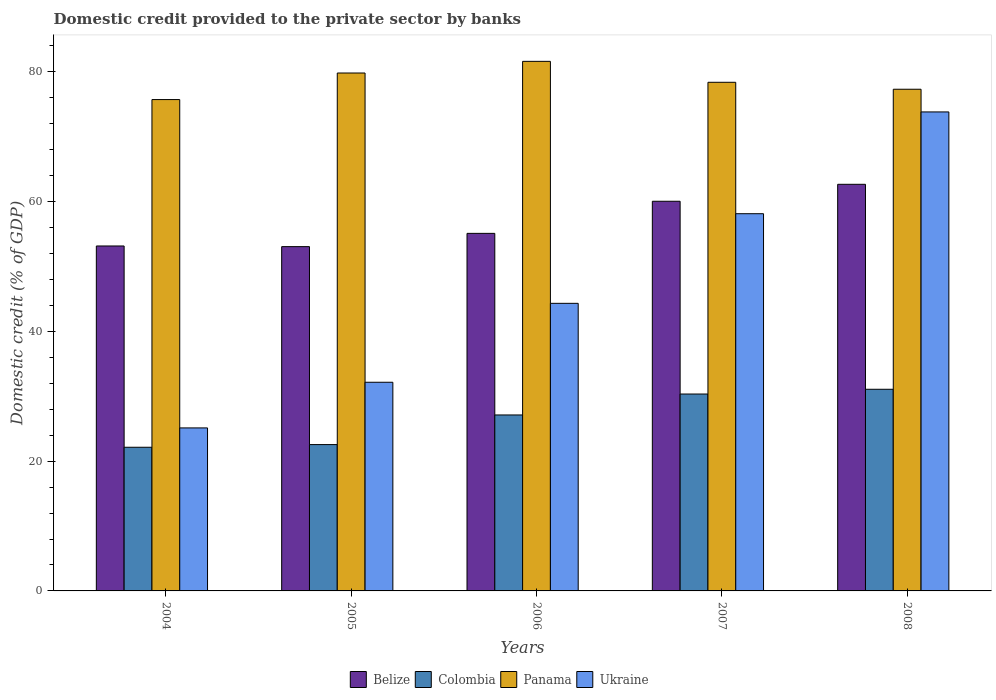Are the number of bars per tick equal to the number of legend labels?
Your answer should be very brief. Yes. How many bars are there on the 5th tick from the left?
Offer a terse response. 4. How many bars are there on the 2nd tick from the right?
Offer a terse response. 4. What is the label of the 4th group of bars from the left?
Your answer should be very brief. 2007. What is the domestic credit provided to the private sector by banks in Colombia in 2005?
Your answer should be compact. 22.56. Across all years, what is the maximum domestic credit provided to the private sector by banks in Colombia?
Keep it short and to the point. 31.08. Across all years, what is the minimum domestic credit provided to the private sector by banks in Panama?
Your answer should be very brief. 75.74. In which year was the domestic credit provided to the private sector by banks in Panama maximum?
Give a very brief answer. 2006. What is the total domestic credit provided to the private sector by banks in Ukraine in the graph?
Ensure brevity in your answer.  233.59. What is the difference between the domestic credit provided to the private sector by banks in Ukraine in 2006 and that in 2008?
Ensure brevity in your answer.  -29.5. What is the difference between the domestic credit provided to the private sector by banks in Colombia in 2008 and the domestic credit provided to the private sector by banks in Belize in 2005?
Provide a short and direct response. -21.99. What is the average domestic credit provided to the private sector by banks in Ukraine per year?
Make the answer very short. 46.72. In the year 2005, what is the difference between the domestic credit provided to the private sector by banks in Colombia and domestic credit provided to the private sector by banks in Belize?
Make the answer very short. -30.51. In how many years, is the domestic credit provided to the private sector by banks in Panama greater than 20 %?
Offer a terse response. 5. What is the ratio of the domestic credit provided to the private sector by banks in Colombia in 2006 to that in 2007?
Your answer should be very brief. 0.89. What is the difference between the highest and the second highest domestic credit provided to the private sector by banks in Panama?
Offer a terse response. 1.8. What is the difference between the highest and the lowest domestic credit provided to the private sector by banks in Ukraine?
Offer a terse response. 48.71. In how many years, is the domestic credit provided to the private sector by banks in Ukraine greater than the average domestic credit provided to the private sector by banks in Ukraine taken over all years?
Offer a terse response. 2. Is the sum of the domestic credit provided to the private sector by banks in Belize in 2006 and 2008 greater than the maximum domestic credit provided to the private sector by banks in Ukraine across all years?
Your answer should be very brief. Yes. What does the 2nd bar from the left in 2008 represents?
Ensure brevity in your answer.  Colombia. What does the 2nd bar from the right in 2008 represents?
Offer a very short reply. Panama. Are all the bars in the graph horizontal?
Make the answer very short. No. How many years are there in the graph?
Provide a short and direct response. 5. Does the graph contain grids?
Make the answer very short. No. What is the title of the graph?
Your response must be concise. Domestic credit provided to the private sector by banks. What is the label or title of the X-axis?
Keep it short and to the point. Years. What is the label or title of the Y-axis?
Ensure brevity in your answer.  Domestic credit (% of GDP). What is the Domestic credit (% of GDP) in Belize in 2004?
Make the answer very short. 53.17. What is the Domestic credit (% of GDP) in Colombia in 2004?
Provide a short and direct response. 22.15. What is the Domestic credit (% of GDP) in Panama in 2004?
Offer a very short reply. 75.74. What is the Domestic credit (% of GDP) of Ukraine in 2004?
Your answer should be compact. 25.13. What is the Domestic credit (% of GDP) in Belize in 2005?
Offer a very short reply. 53.07. What is the Domestic credit (% of GDP) in Colombia in 2005?
Your response must be concise. 22.56. What is the Domestic credit (% of GDP) of Panama in 2005?
Make the answer very short. 79.83. What is the Domestic credit (% of GDP) of Ukraine in 2005?
Provide a succinct answer. 32.16. What is the Domestic credit (% of GDP) of Belize in 2006?
Your answer should be compact. 55.11. What is the Domestic credit (% of GDP) of Colombia in 2006?
Offer a very short reply. 27.12. What is the Domestic credit (% of GDP) of Panama in 2006?
Offer a terse response. 81.63. What is the Domestic credit (% of GDP) of Ukraine in 2006?
Give a very brief answer. 44.33. What is the Domestic credit (% of GDP) of Belize in 2007?
Offer a terse response. 60.06. What is the Domestic credit (% of GDP) of Colombia in 2007?
Provide a succinct answer. 30.35. What is the Domestic credit (% of GDP) in Panama in 2007?
Give a very brief answer. 78.4. What is the Domestic credit (% of GDP) in Ukraine in 2007?
Make the answer very short. 58.14. What is the Domestic credit (% of GDP) in Belize in 2008?
Offer a very short reply. 62.68. What is the Domestic credit (% of GDP) in Colombia in 2008?
Keep it short and to the point. 31.08. What is the Domestic credit (% of GDP) of Panama in 2008?
Your answer should be compact. 77.33. What is the Domestic credit (% of GDP) of Ukraine in 2008?
Offer a terse response. 73.83. Across all years, what is the maximum Domestic credit (% of GDP) in Belize?
Ensure brevity in your answer.  62.68. Across all years, what is the maximum Domestic credit (% of GDP) of Colombia?
Offer a very short reply. 31.08. Across all years, what is the maximum Domestic credit (% of GDP) in Panama?
Provide a short and direct response. 81.63. Across all years, what is the maximum Domestic credit (% of GDP) of Ukraine?
Ensure brevity in your answer.  73.83. Across all years, what is the minimum Domestic credit (% of GDP) in Belize?
Provide a succinct answer. 53.07. Across all years, what is the minimum Domestic credit (% of GDP) of Colombia?
Provide a short and direct response. 22.15. Across all years, what is the minimum Domestic credit (% of GDP) of Panama?
Your response must be concise. 75.74. Across all years, what is the minimum Domestic credit (% of GDP) in Ukraine?
Your answer should be compact. 25.13. What is the total Domestic credit (% of GDP) in Belize in the graph?
Your response must be concise. 284.09. What is the total Domestic credit (% of GDP) in Colombia in the graph?
Your answer should be compact. 133.26. What is the total Domestic credit (% of GDP) of Panama in the graph?
Make the answer very short. 392.92. What is the total Domestic credit (% of GDP) of Ukraine in the graph?
Provide a succinct answer. 233.59. What is the difference between the Domestic credit (% of GDP) in Belize in 2004 and that in 2005?
Make the answer very short. 0.1. What is the difference between the Domestic credit (% of GDP) of Colombia in 2004 and that in 2005?
Provide a succinct answer. -0.41. What is the difference between the Domestic credit (% of GDP) in Panama in 2004 and that in 2005?
Provide a succinct answer. -4.1. What is the difference between the Domestic credit (% of GDP) in Ukraine in 2004 and that in 2005?
Offer a terse response. -7.04. What is the difference between the Domestic credit (% of GDP) in Belize in 2004 and that in 2006?
Provide a short and direct response. -1.94. What is the difference between the Domestic credit (% of GDP) in Colombia in 2004 and that in 2006?
Offer a very short reply. -4.98. What is the difference between the Domestic credit (% of GDP) of Panama in 2004 and that in 2006?
Offer a very short reply. -5.89. What is the difference between the Domestic credit (% of GDP) in Ukraine in 2004 and that in 2006?
Provide a short and direct response. -19.2. What is the difference between the Domestic credit (% of GDP) in Belize in 2004 and that in 2007?
Keep it short and to the point. -6.89. What is the difference between the Domestic credit (% of GDP) in Colombia in 2004 and that in 2007?
Your response must be concise. -8.21. What is the difference between the Domestic credit (% of GDP) of Panama in 2004 and that in 2007?
Provide a short and direct response. -2.66. What is the difference between the Domestic credit (% of GDP) of Ukraine in 2004 and that in 2007?
Your answer should be very brief. -33.02. What is the difference between the Domestic credit (% of GDP) in Belize in 2004 and that in 2008?
Your answer should be compact. -9.51. What is the difference between the Domestic credit (% of GDP) in Colombia in 2004 and that in 2008?
Offer a terse response. -8.94. What is the difference between the Domestic credit (% of GDP) in Panama in 2004 and that in 2008?
Provide a succinct answer. -1.59. What is the difference between the Domestic credit (% of GDP) in Ukraine in 2004 and that in 2008?
Your answer should be very brief. -48.71. What is the difference between the Domestic credit (% of GDP) in Belize in 2005 and that in 2006?
Keep it short and to the point. -2.04. What is the difference between the Domestic credit (% of GDP) of Colombia in 2005 and that in 2006?
Your response must be concise. -4.57. What is the difference between the Domestic credit (% of GDP) in Panama in 2005 and that in 2006?
Provide a short and direct response. -1.8. What is the difference between the Domestic credit (% of GDP) of Ukraine in 2005 and that in 2006?
Your response must be concise. -12.17. What is the difference between the Domestic credit (% of GDP) in Belize in 2005 and that in 2007?
Ensure brevity in your answer.  -6.99. What is the difference between the Domestic credit (% of GDP) of Colombia in 2005 and that in 2007?
Give a very brief answer. -7.79. What is the difference between the Domestic credit (% of GDP) in Panama in 2005 and that in 2007?
Ensure brevity in your answer.  1.43. What is the difference between the Domestic credit (% of GDP) of Ukraine in 2005 and that in 2007?
Provide a short and direct response. -25.98. What is the difference between the Domestic credit (% of GDP) of Belize in 2005 and that in 2008?
Ensure brevity in your answer.  -9.61. What is the difference between the Domestic credit (% of GDP) of Colombia in 2005 and that in 2008?
Provide a short and direct response. -8.52. What is the difference between the Domestic credit (% of GDP) in Panama in 2005 and that in 2008?
Ensure brevity in your answer.  2.5. What is the difference between the Domestic credit (% of GDP) of Ukraine in 2005 and that in 2008?
Keep it short and to the point. -41.67. What is the difference between the Domestic credit (% of GDP) in Belize in 2006 and that in 2007?
Keep it short and to the point. -4.95. What is the difference between the Domestic credit (% of GDP) of Colombia in 2006 and that in 2007?
Your answer should be compact. -3.23. What is the difference between the Domestic credit (% of GDP) of Panama in 2006 and that in 2007?
Provide a succinct answer. 3.23. What is the difference between the Domestic credit (% of GDP) of Ukraine in 2006 and that in 2007?
Keep it short and to the point. -13.81. What is the difference between the Domestic credit (% of GDP) of Belize in 2006 and that in 2008?
Your response must be concise. -7.56. What is the difference between the Domestic credit (% of GDP) in Colombia in 2006 and that in 2008?
Provide a succinct answer. -3.96. What is the difference between the Domestic credit (% of GDP) of Panama in 2006 and that in 2008?
Keep it short and to the point. 4.3. What is the difference between the Domestic credit (% of GDP) in Ukraine in 2006 and that in 2008?
Offer a terse response. -29.5. What is the difference between the Domestic credit (% of GDP) of Belize in 2007 and that in 2008?
Your answer should be compact. -2.61. What is the difference between the Domestic credit (% of GDP) in Colombia in 2007 and that in 2008?
Provide a short and direct response. -0.73. What is the difference between the Domestic credit (% of GDP) in Panama in 2007 and that in 2008?
Your answer should be very brief. 1.07. What is the difference between the Domestic credit (% of GDP) of Ukraine in 2007 and that in 2008?
Provide a succinct answer. -15.69. What is the difference between the Domestic credit (% of GDP) of Belize in 2004 and the Domestic credit (% of GDP) of Colombia in 2005?
Ensure brevity in your answer.  30.61. What is the difference between the Domestic credit (% of GDP) of Belize in 2004 and the Domestic credit (% of GDP) of Panama in 2005?
Give a very brief answer. -26.66. What is the difference between the Domestic credit (% of GDP) of Belize in 2004 and the Domestic credit (% of GDP) of Ukraine in 2005?
Ensure brevity in your answer.  21.01. What is the difference between the Domestic credit (% of GDP) of Colombia in 2004 and the Domestic credit (% of GDP) of Panama in 2005?
Offer a terse response. -57.69. What is the difference between the Domestic credit (% of GDP) in Colombia in 2004 and the Domestic credit (% of GDP) in Ukraine in 2005?
Offer a very short reply. -10.02. What is the difference between the Domestic credit (% of GDP) of Panama in 2004 and the Domestic credit (% of GDP) of Ukraine in 2005?
Your answer should be very brief. 43.57. What is the difference between the Domestic credit (% of GDP) of Belize in 2004 and the Domestic credit (% of GDP) of Colombia in 2006?
Offer a very short reply. 26.05. What is the difference between the Domestic credit (% of GDP) of Belize in 2004 and the Domestic credit (% of GDP) of Panama in 2006?
Your answer should be very brief. -28.46. What is the difference between the Domestic credit (% of GDP) in Belize in 2004 and the Domestic credit (% of GDP) in Ukraine in 2006?
Your answer should be compact. 8.84. What is the difference between the Domestic credit (% of GDP) in Colombia in 2004 and the Domestic credit (% of GDP) in Panama in 2006?
Offer a very short reply. -59.48. What is the difference between the Domestic credit (% of GDP) of Colombia in 2004 and the Domestic credit (% of GDP) of Ukraine in 2006?
Make the answer very short. -22.18. What is the difference between the Domestic credit (% of GDP) in Panama in 2004 and the Domestic credit (% of GDP) in Ukraine in 2006?
Give a very brief answer. 31.41. What is the difference between the Domestic credit (% of GDP) of Belize in 2004 and the Domestic credit (% of GDP) of Colombia in 2007?
Your answer should be very brief. 22.82. What is the difference between the Domestic credit (% of GDP) in Belize in 2004 and the Domestic credit (% of GDP) in Panama in 2007?
Your answer should be very brief. -25.23. What is the difference between the Domestic credit (% of GDP) in Belize in 2004 and the Domestic credit (% of GDP) in Ukraine in 2007?
Give a very brief answer. -4.97. What is the difference between the Domestic credit (% of GDP) of Colombia in 2004 and the Domestic credit (% of GDP) of Panama in 2007?
Your response must be concise. -56.25. What is the difference between the Domestic credit (% of GDP) of Colombia in 2004 and the Domestic credit (% of GDP) of Ukraine in 2007?
Offer a very short reply. -36. What is the difference between the Domestic credit (% of GDP) of Panama in 2004 and the Domestic credit (% of GDP) of Ukraine in 2007?
Offer a terse response. 17.59. What is the difference between the Domestic credit (% of GDP) of Belize in 2004 and the Domestic credit (% of GDP) of Colombia in 2008?
Give a very brief answer. 22.09. What is the difference between the Domestic credit (% of GDP) in Belize in 2004 and the Domestic credit (% of GDP) in Panama in 2008?
Keep it short and to the point. -24.16. What is the difference between the Domestic credit (% of GDP) in Belize in 2004 and the Domestic credit (% of GDP) in Ukraine in 2008?
Offer a terse response. -20.66. What is the difference between the Domestic credit (% of GDP) of Colombia in 2004 and the Domestic credit (% of GDP) of Panama in 2008?
Your response must be concise. -55.18. What is the difference between the Domestic credit (% of GDP) in Colombia in 2004 and the Domestic credit (% of GDP) in Ukraine in 2008?
Ensure brevity in your answer.  -51.69. What is the difference between the Domestic credit (% of GDP) in Panama in 2004 and the Domestic credit (% of GDP) in Ukraine in 2008?
Provide a short and direct response. 1.91. What is the difference between the Domestic credit (% of GDP) in Belize in 2005 and the Domestic credit (% of GDP) in Colombia in 2006?
Provide a short and direct response. 25.95. What is the difference between the Domestic credit (% of GDP) of Belize in 2005 and the Domestic credit (% of GDP) of Panama in 2006?
Offer a very short reply. -28.56. What is the difference between the Domestic credit (% of GDP) of Belize in 2005 and the Domestic credit (% of GDP) of Ukraine in 2006?
Provide a short and direct response. 8.74. What is the difference between the Domestic credit (% of GDP) of Colombia in 2005 and the Domestic credit (% of GDP) of Panama in 2006?
Offer a terse response. -59.07. What is the difference between the Domestic credit (% of GDP) in Colombia in 2005 and the Domestic credit (% of GDP) in Ukraine in 2006?
Ensure brevity in your answer.  -21.77. What is the difference between the Domestic credit (% of GDP) of Panama in 2005 and the Domestic credit (% of GDP) of Ukraine in 2006?
Offer a terse response. 35.5. What is the difference between the Domestic credit (% of GDP) of Belize in 2005 and the Domestic credit (% of GDP) of Colombia in 2007?
Provide a succinct answer. 22.72. What is the difference between the Domestic credit (% of GDP) in Belize in 2005 and the Domestic credit (% of GDP) in Panama in 2007?
Your answer should be compact. -25.33. What is the difference between the Domestic credit (% of GDP) in Belize in 2005 and the Domestic credit (% of GDP) in Ukraine in 2007?
Ensure brevity in your answer.  -5.07. What is the difference between the Domestic credit (% of GDP) of Colombia in 2005 and the Domestic credit (% of GDP) of Panama in 2007?
Provide a succinct answer. -55.84. What is the difference between the Domestic credit (% of GDP) in Colombia in 2005 and the Domestic credit (% of GDP) in Ukraine in 2007?
Your answer should be compact. -35.58. What is the difference between the Domestic credit (% of GDP) of Panama in 2005 and the Domestic credit (% of GDP) of Ukraine in 2007?
Your response must be concise. 21.69. What is the difference between the Domestic credit (% of GDP) in Belize in 2005 and the Domestic credit (% of GDP) in Colombia in 2008?
Ensure brevity in your answer.  21.99. What is the difference between the Domestic credit (% of GDP) in Belize in 2005 and the Domestic credit (% of GDP) in Panama in 2008?
Provide a succinct answer. -24.26. What is the difference between the Domestic credit (% of GDP) of Belize in 2005 and the Domestic credit (% of GDP) of Ukraine in 2008?
Make the answer very short. -20.76. What is the difference between the Domestic credit (% of GDP) of Colombia in 2005 and the Domestic credit (% of GDP) of Panama in 2008?
Your response must be concise. -54.77. What is the difference between the Domestic credit (% of GDP) in Colombia in 2005 and the Domestic credit (% of GDP) in Ukraine in 2008?
Ensure brevity in your answer.  -51.27. What is the difference between the Domestic credit (% of GDP) of Panama in 2005 and the Domestic credit (% of GDP) of Ukraine in 2008?
Offer a very short reply. 6. What is the difference between the Domestic credit (% of GDP) of Belize in 2006 and the Domestic credit (% of GDP) of Colombia in 2007?
Provide a succinct answer. 24.76. What is the difference between the Domestic credit (% of GDP) in Belize in 2006 and the Domestic credit (% of GDP) in Panama in 2007?
Your answer should be compact. -23.29. What is the difference between the Domestic credit (% of GDP) in Belize in 2006 and the Domestic credit (% of GDP) in Ukraine in 2007?
Provide a short and direct response. -3.03. What is the difference between the Domestic credit (% of GDP) in Colombia in 2006 and the Domestic credit (% of GDP) in Panama in 2007?
Keep it short and to the point. -51.28. What is the difference between the Domestic credit (% of GDP) in Colombia in 2006 and the Domestic credit (% of GDP) in Ukraine in 2007?
Your response must be concise. -31.02. What is the difference between the Domestic credit (% of GDP) of Panama in 2006 and the Domestic credit (% of GDP) of Ukraine in 2007?
Provide a short and direct response. 23.49. What is the difference between the Domestic credit (% of GDP) of Belize in 2006 and the Domestic credit (% of GDP) of Colombia in 2008?
Offer a terse response. 24.03. What is the difference between the Domestic credit (% of GDP) in Belize in 2006 and the Domestic credit (% of GDP) in Panama in 2008?
Offer a terse response. -22.22. What is the difference between the Domestic credit (% of GDP) in Belize in 2006 and the Domestic credit (% of GDP) in Ukraine in 2008?
Keep it short and to the point. -18.72. What is the difference between the Domestic credit (% of GDP) of Colombia in 2006 and the Domestic credit (% of GDP) of Panama in 2008?
Your response must be concise. -50.21. What is the difference between the Domestic credit (% of GDP) of Colombia in 2006 and the Domestic credit (% of GDP) of Ukraine in 2008?
Your answer should be very brief. -46.71. What is the difference between the Domestic credit (% of GDP) of Panama in 2006 and the Domestic credit (% of GDP) of Ukraine in 2008?
Provide a succinct answer. 7.8. What is the difference between the Domestic credit (% of GDP) of Belize in 2007 and the Domestic credit (% of GDP) of Colombia in 2008?
Give a very brief answer. 28.98. What is the difference between the Domestic credit (% of GDP) of Belize in 2007 and the Domestic credit (% of GDP) of Panama in 2008?
Provide a short and direct response. -17.27. What is the difference between the Domestic credit (% of GDP) of Belize in 2007 and the Domestic credit (% of GDP) of Ukraine in 2008?
Ensure brevity in your answer.  -13.77. What is the difference between the Domestic credit (% of GDP) of Colombia in 2007 and the Domestic credit (% of GDP) of Panama in 2008?
Your answer should be compact. -46.98. What is the difference between the Domestic credit (% of GDP) in Colombia in 2007 and the Domestic credit (% of GDP) in Ukraine in 2008?
Your answer should be very brief. -43.48. What is the difference between the Domestic credit (% of GDP) of Panama in 2007 and the Domestic credit (% of GDP) of Ukraine in 2008?
Your response must be concise. 4.57. What is the average Domestic credit (% of GDP) in Belize per year?
Give a very brief answer. 56.82. What is the average Domestic credit (% of GDP) in Colombia per year?
Ensure brevity in your answer.  26.65. What is the average Domestic credit (% of GDP) in Panama per year?
Make the answer very short. 78.58. What is the average Domestic credit (% of GDP) of Ukraine per year?
Ensure brevity in your answer.  46.72. In the year 2004, what is the difference between the Domestic credit (% of GDP) in Belize and Domestic credit (% of GDP) in Colombia?
Offer a very short reply. 31.02. In the year 2004, what is the difference between the Domestic credit (% of GDP) in Belize and Domestic credit (% of GDP) in Panama?
Ensure brevity in your answer.  -22.57. In the year 2004, what is the difference between the Domestic credit (% of GDP) in Belize and Domestic credit (% of GDP) in Ukraine?
Make the answer very short. 28.04. In the year 2004, what is the difference between the Domestic credit (% of GDP) in Colombia and Domestic credit (% of GDP) in Panama?
Ensure brevity in your answer.  -53.59. In the year 2004, what is the difference between the Domestic credit (% of GDP) of Colombia and Domestic credit (% of GDP) of Ukraine?
Offer a terse response. -2.98. In the year 2004, what is the difference between the Domestic credit (% of GDP) in Panama and Domestic credit (% of GDP) in Ukraine?
Ensure brevity in your answer.  50.61. In the year 2005, what is the difference between the Domestic credit (% of GDP) in Belize and Domestic credit (% of GDP) in Colombia?
Give a very brief answer. 30.51. In the year 2005, what is the difference between the Domestic credit (% of GDP) in Belize and Domestic credit (% of GDP) in Panama?
Your response must be concise. -26.76. In the year 2005, what is the difference between the Domestic credit (% of GDP) of Belize and Domestic credit (% of GDP) of Ukraine?
Offer a terse response. 20.9. In the year 2005, what is the difference between the Domestic credit (% of GDP) in Colombia and Domestic credit (% of GDP) in Panama?
Give a very brief answer. -57.27. In the year 2005, what is the difference between the Domestic credit (% of GDP) of Colombia and Domestic credit (% of GDP) of Ukraine?
Ensure brevity in your answer.  -9.61. In the year 2005, what is the difference between the Domestic credit (% of GDP) in Panama and Domestic credit (% of GDP) in Ukraine?
Offer a very short reply. 47.67. In the year 2006, what is the difference between the Domestic credit (% of GDP) in Belize and Domestic credit (% of GDP) in Colombia?
Offer a terse response. 27.99. In the year 2006, what is the difference between the Domestic credit (% of GDP) of Belize and Domestic credit (% of GDP) of Panama?
Keep it short and to the point. -26.51. In the year 2006, what is the difference between the Domestic credit (% of GDP) of Belize and Domestic credit (% of GDP) of Ukraine?
Provide a succinct answer. 10.78. In the year 2006, what is the difference between the Domestic credit (% of GDP) in Colombia and Domestic credit (% of GDP) in Panama?
Make the answer very short. -54.5. In the year 2006, what is the difference between the Domestic credit (% of GDP) in Colombia and Domestic credit (% of GDP) in Ukraine?
Provide a succinct answer. -17.21. In the year 2006, what is the difference between the Domestic credit (% of GDP) in Panama and Domestic credit (% of GDP) in Ukraine?
Provide a succinct answer. 37.3. In the year 2007, what is the difference between the Domestic credit (% of GDP) in Belize and Domestic credit (% of GDP) in Colombia?
Ensure brevity in your answer.  29.71. In the year 2007, what is the difference between the Domestic credit (% of GDP) in Belize and Domestic credit (% of GDP) in Panama?
Offer a terse response. -18.34. In the year 2007, what is the difference between the Domestic credit (% of GDP) of Belize and Domestic credit (% of GDP) of Ukraine?
Offer a terse response. 1.92. In the year 2007, what is the difference between the Domestic credit (% of GDP) of Colombia and Domestic credit (% of GDP) of Panama?
Provide a succinct answer. -48.05. In the year 2007, what is the difference between the Domestic credit (% of GDP) in Colombia and Domestic credit (% of GDP) in Ukraine?
Offer a very short reply. -27.79. In the year 2007, what is the difference between the Domestic credit (% of GDP) of Panama and Domestic credit (% of GDP) of Ukraine?
Offer a terse response. 20.26. In the year 2008, what is the difference between the Domestic credit (% of GDP) of Belize and Domestic credit (% of GDP) of Colombia?
Provide a succinct answer. 31.6. In the year 2008, what is the difference between the Domestic credit (% of GDP) in Belize and Domestic credit (% of GDP) in Panama?
Offer a very short reply. -14.65. In the year 2008, what is the difference between the Domestic credit (% of GDP) in Belize and Domestic credit (% of GDP) in Ukraine?
Provide a succinct answer. -11.15. In the year 2008, what is the difference between the Domestic credit (% of GDP) in Colombia and Domestic credit (% of GDP) in Panama?
Your response must be concise. -46.25. In the year 2008, what is the difference between the Domestic credit (% of GDP) of Colombia and Domestic credit (% of GDP) of Ukraine?
Provide a succinct answer. -42.75. In the year 2008, what is the difference between the Domestic credit (% of GDP) of Panama and Domestic credit (% of GDP) of Ukraine?
Keep it short and to the point. 3.5. What is the ratio of the Domestic credit (% of GDP) of Colombia in 2004 to that in 2005?
Your response must be concise. 0.98. What is the ratio of the Domestic credit (% of GDP) in Panama in 2004 to that in 2005?
Offer a terse response. 0.95. What is the ratio of the Domestic credit (% of GDP) of Ukraine in 2004 to that in 2005?
Your answer should be compact. 0.78. What is the ratio of the Domestic credit (% of GDP) in Belize in 2004 to that in 2006?
Offer a very short reply. 0.96. What is the ratio of the Domestic credit (% of GDP) in Colombia in 2004 to that in 2006?
Keep it short and to the point. 0.82. What is the ratio of the Domestic credit (% of GDP) in Panama in 2004 to that in 2006?
Your answer should be compact. 0.93. What is the ratio of the Domestic credit (% of GDP) of Ukraine in 2004 to that in 2006?
Your answer should be very brief. 0.57. What is the ratio of the Domestic credit (% of GDP) in Belize in 2004 to that in 2007?
Provide a succinct answer. 0.89. What is the ratio of the Domestic credit (% of GDP) of Colombia in 2004 to that in 2007?
Your answer should be very brief. 0.73. What is the ratio of the Domestic credit (% of GDP) of Panama in 2004 to that in 2007?
Keep it short and to the point. 0.97. What is the ratio of the Domestic credit (% of GDP) in Ukraine in 2004 to that in 2007?
Provide a short and direct response. 0.43. What is the ratio of the Domestic credit (% of GDP) of Belize in 2004 to that in 2008?
Provide a short and direct response. 0.85. What is the ratio of the Domestic credit (% of GDP) of Colombia in 2004 to that in 2008?
Provide a short and direct response. 0.71. What is the ratio of the Domestic credit (% of GDP) in Panama in 2004 to that in 2008?
Keep it short and to the point. 0.98. What is the ratio of the Domestic credit (% of GDP) of Ukraine in 2004 to that in 2008?
Keep it short and to the point. 0.34. What is the ratio of the Domestic credit (% of GDP) of Belize in 2005 to that in 2006?
Your answer should be very brief. 0.96. What is the ratio of the Domestic credit (% of GDP) of Colombia in 2005 to that in 2006?
Provide a short and direct response. 0.83. What is the ratio of the Domestic credit (% of GDP) of Panama in 2005 to that in 2006?
Keep it short and to the point. 0.98. What is the ratio of the Domestic credit (% of GDP) in Ukraine in 2005 to that in 2006?
Make the answer very short. 0.73. What is the ratio of the Domestic credit (% of GDP) of Belize in 2005 to that in 2007?
Your answer should be compact. 0.88. What is the ratio of the Domestic credit (% of GDP) of Colombia in 2005 to that in 2007?
Your answer should be compact. 0.74. What is the ratio of the Domestic credit (% of GDP) of Panama in 2005 to that in 2007?
Provide a succinct answer. 1.02. What is the ratio of the Domestic credit (% of GDP) in Ukraine in 2005 to that in 2007?
Provide a succinct answer. 0.55. What is the ratio of the Domestic credit (% of GDP) in Belize in 2005 to that in 2008?
Offer a very short reply. 0.85. What is the ratio of the Domestic credit (% of GDP) in Colombia in 2005 to that in 2008?
Keep it short and to the point. 0.73. What is the ratio of the Domestic credit (% of GDP) of Panama in 2005 to that in 2008?
Keep it short and to the point. 1.03. What is the ratio of the Domestic credit (% of GDP) of Ukraine in 2005 to that in 2008?
Offer a terse response. 0.44. What is the ratio of the Domestic credit (% of GDP) of Belize in 2006 to that in 2007?
Ensure brevity in your answer.  0.92. What is the ratio of the Domestic credit (% of GDP) in Colombia in 2006 to that in 2007?
Your answer should be very brief. 0.89. What is the ratio of the Domestic credit (% of GDP) in Panama in 2006 to that in 2007?
Offer a terse response. 1.04. What is the ratio of the Domestic credit (% of GDP) of Ukraine in 2006 to that in 2007?
Offer a terse response. 0.76. What is the ratio of the Domestic credit (% of GDP) of Belize in 2006 to that in 2008?
Provide a succinct answer. 0.88. What is the ratio of the Domestic credit (% of GDP) in Colombia in 2006 to that in 2008?
Provide a succinct answer. 0.87. What is the ratio of the Domestic credit (% of GDP) of Panama in 2006 to that in 2008?
Offer a very short reply. 1.06. What is the ratio of the Domestic credit (% of GDP) in Ukraine in 2006 to that in 2008?
Give a very brief answer. 0.6. What is the ratio of the Domestic credit (% of GDP) in Colombia in 2007 to that in 2008?
Provide a succinct answer. 0.98. What is the ratio of the Domestic credit (% of GDP) in Panama in 2007 to that in 2008?
Provide a succinct answer. 1.01. What is the ratio of the Domestic credit (% of GDP) in Ukraine in 2007 to that in 2008?
Offer a terse response. 0.79. What is the difference between the highest and the second highest Domestic credit (% of GDP) of Belize?
Your answer should be compact. 2.61. What is the difference between the highest and the second highest Domestic credit (% of GDP) of Colombia?
Your answer should be compact. 0.73. What is the difference between the highest and the second highest Domestic credit (% of GDP) in Panama?
Keep it short and to the point. 1.8. What is the difference between the highest and the second highest Domestic credit (% of GDP) in Ukraine?
Give a very brief answer. 15.69. What is the difference between the highest and the lowest Domestic credit (% of GDP) in Belize?
Your response must be concise. 9.61. What is the difference between the highest and the lowest Domestic credit (% of GDP) of Colombia?
Your answer should be very brief. 8.94. What is the difference between the highest and the lowest Domestic credit (% of GDP) in Panama?
Give a very brief answer. 5.89. What is the difference between the highest and the lowest Domestic credit (% of GDP) in Ukraine?
Ensure brevity in your answer.  48.71. 